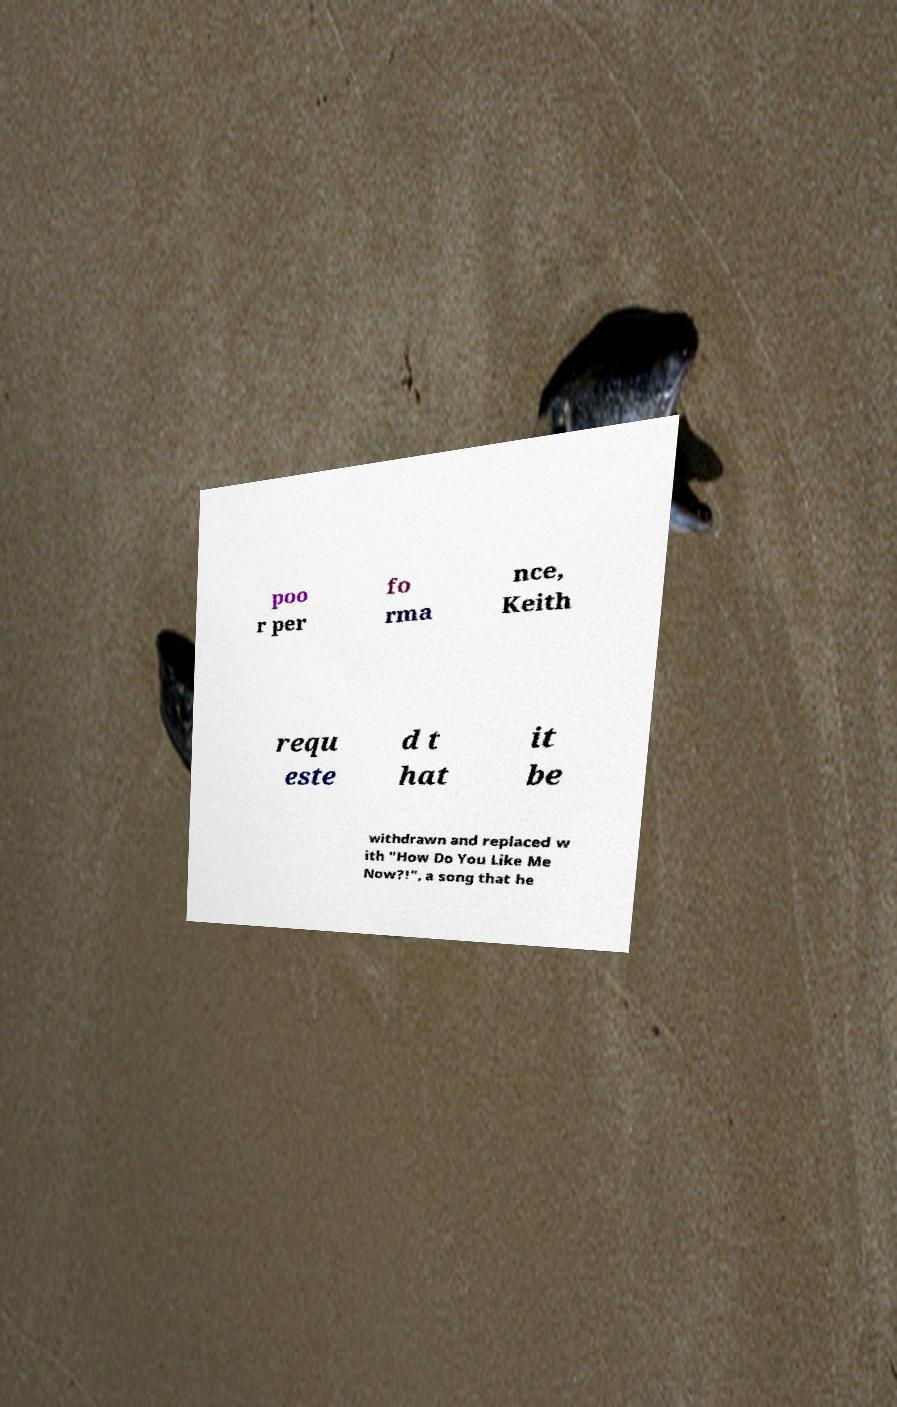Can you read and provide the text displayed in the image?This photo seems to have some interesting text. Can you extract and type it out for me? poo r per fo rma nce, Keith requ este d t hat it be withdrawn and replaced w ith "How Do You Like Me Now?!", a song that he 